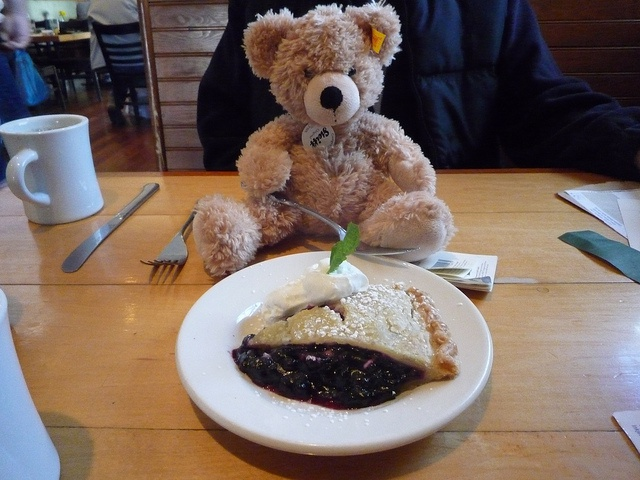Describe the objects in this image and their specific colors. I can see dining table in lightgray, gray, tan, darkgray, and olive tones, people in lightgray, black, navy, gray, and darkgray tones, teddy bear in lightgray, gray, darkgray, and maroon tones, cup in lightgray, gray, lightblue, and darkgray tones, and cup in lightgray, lightblue, and darkgray tones in this image. 